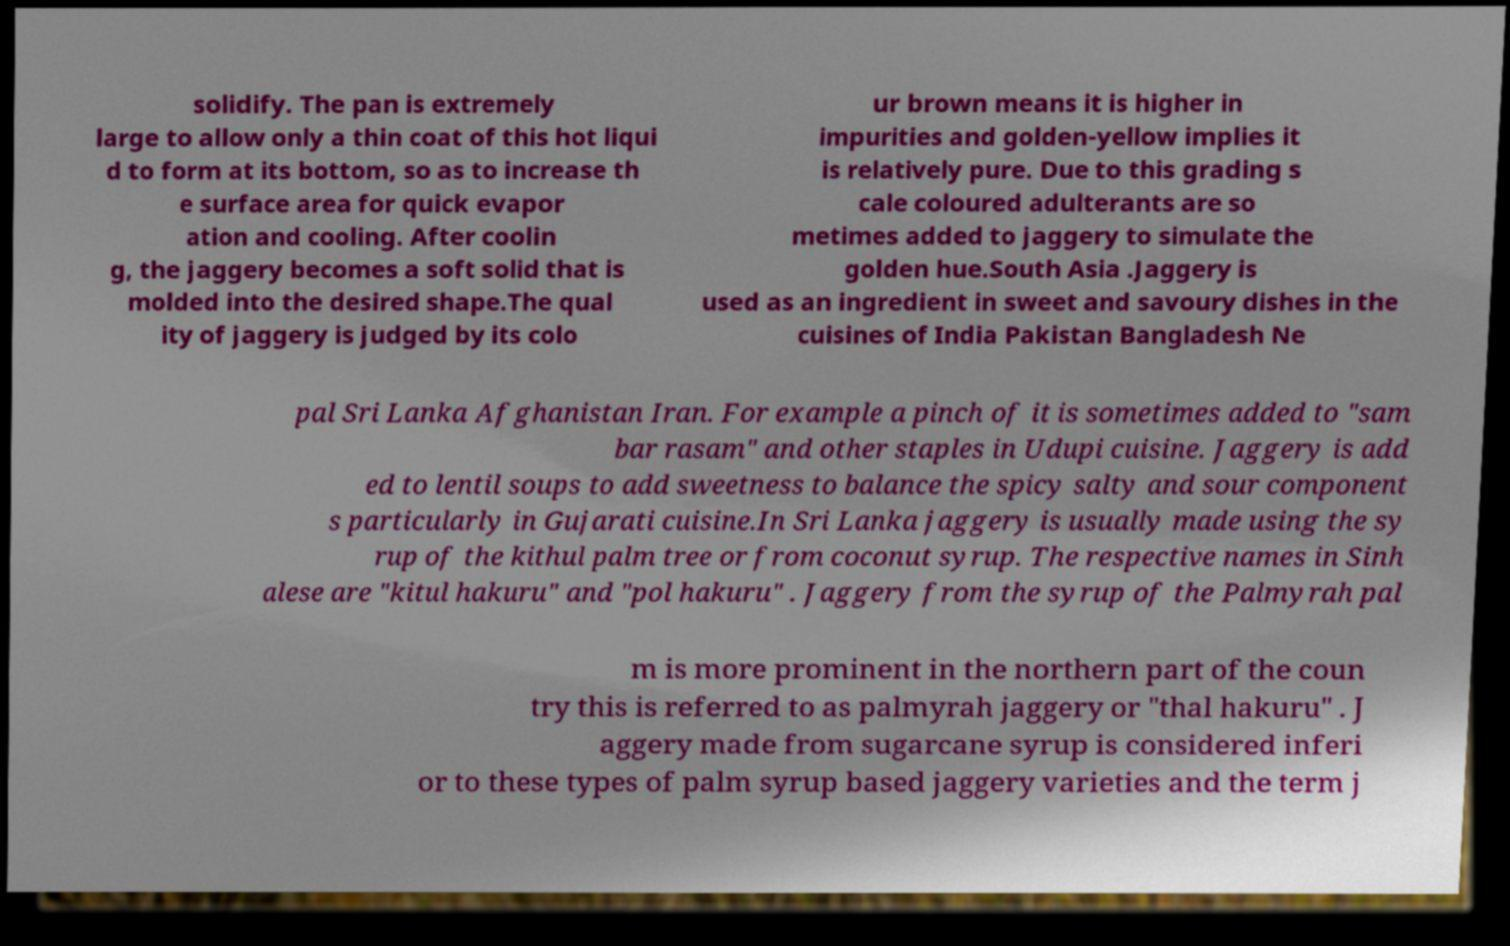I need the written content from this picture converted into text. Can you do that? solidify. The pan is extremely large to allow only a thin coat of this hot liqui d to form at its bottom, so as to increase th e surface area for quick evapor ation and cooling. After coolin g, the jaggery becomes a soft solid that is molded into the desired shape.The qual ity of jaggery is judged by its colo ur brown means it is higher in impurities and golden-yellow implies it is relatively pure. Due to this grading s cale coloured adulterants are so metimes added to jaggery to simulate the golden hue.South Asia .Jaggery is used as an ingredient in sweet and savoury dishes in the cuisines of India Pakistan Bangladesh Ne pal Sri Lanka Afghanistan Iran. For example a pinch of it is sometimes added to "sam bar rasam" and other staples in Udupi cuisine. Jaggery is add ed to lentil soups to add sweetness to balance the spicy salty and sour component s particularly in Gujarati cuisine.In Sri Lanka jaggery is usually made using the sy rup of the kithul palm tree or from coconut syrup. The respective names in Sinh alese are "kitul hakuru" and "pol hakuru" . Jaggery from the syrup of the Palmyrah pal m is more prominent in the northern part of the coun try this is referred to as palmyrah jaggery or "thal hakuru" . J aggery made from sugarcane syrup is considered inferi or to these types of palm syrup based jaggery varieties and the term j 